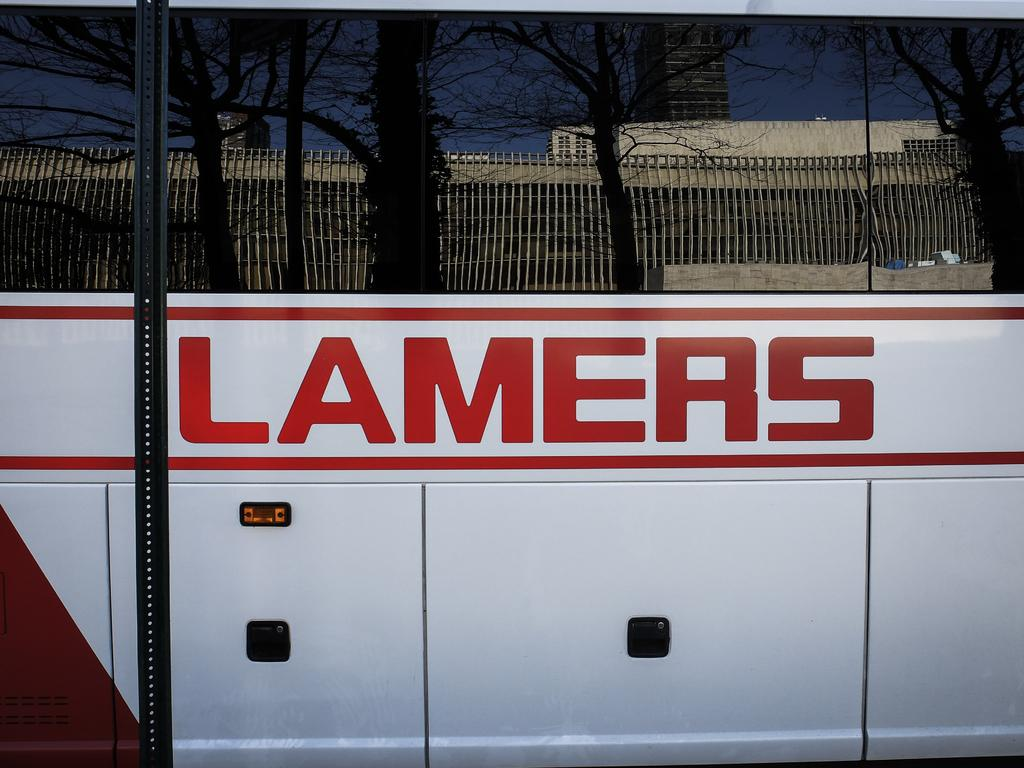What is the main subject of the image? The main subject of the image is a vehicle. What can be seen written on the vehicle? The vehicle has "Lamers" written on it. What is visible in the vehicle's mirror? The vehicle's mirror reflects buildings and trees. What is the name of the manager's daughter who is sitting in the vehicle? There is no person, let alone a manager's daughter, present in the image. The image only shows a vehicle with "Lamers" written on it and its mirror reflecting buildings and trees. 